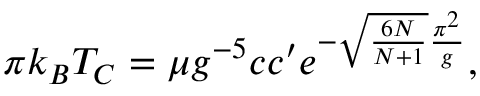<formula> <loc_0><loc_0><loc_500><loc_500>\pi k _ { B } T _ { C } = \mu g ^ { - 5 } c c ^ { \prime } e ^ { - \sqrt { { \frac { 6 N } { N + 1 } } } { \frac { \pi ^ { 2 } } { g } } } ,</formula> 